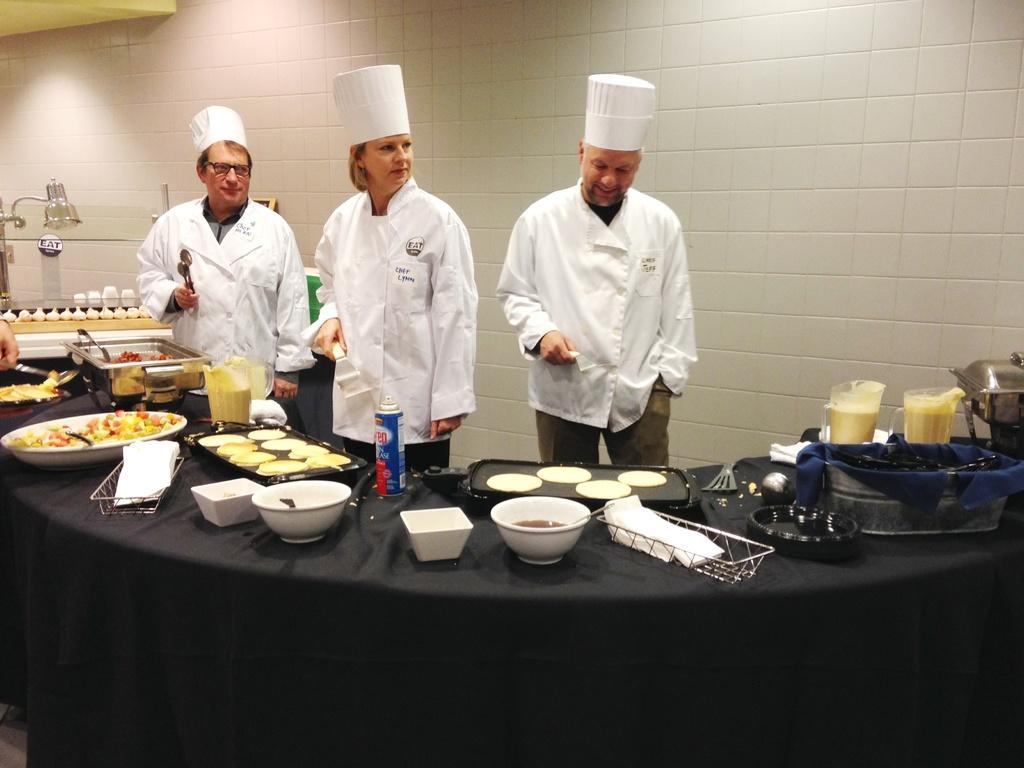Can you describe this image briefly? In this picture we can see two men and a woman standing, there is a table in the front, we can see some bowls, trays, baskets, jars and a spray present on the table, in the background there is a wall, these three persons wore caps, we can see some food in these trays and bowl, there are some tissue papers here. 